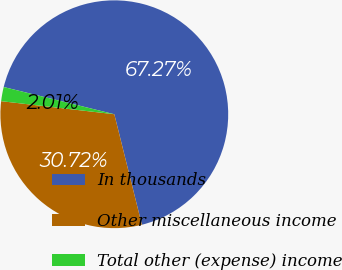Convert chart. <chart><loc_0><loc_0><loc_500><loc_500><pie_chart><fcel>In thousands<fcel>Other miscellaneous income<fcel>Total other (expense) income<nl><fcel>67.27%<fcel>30.72%<fcel>2.01%<nl></chart> 